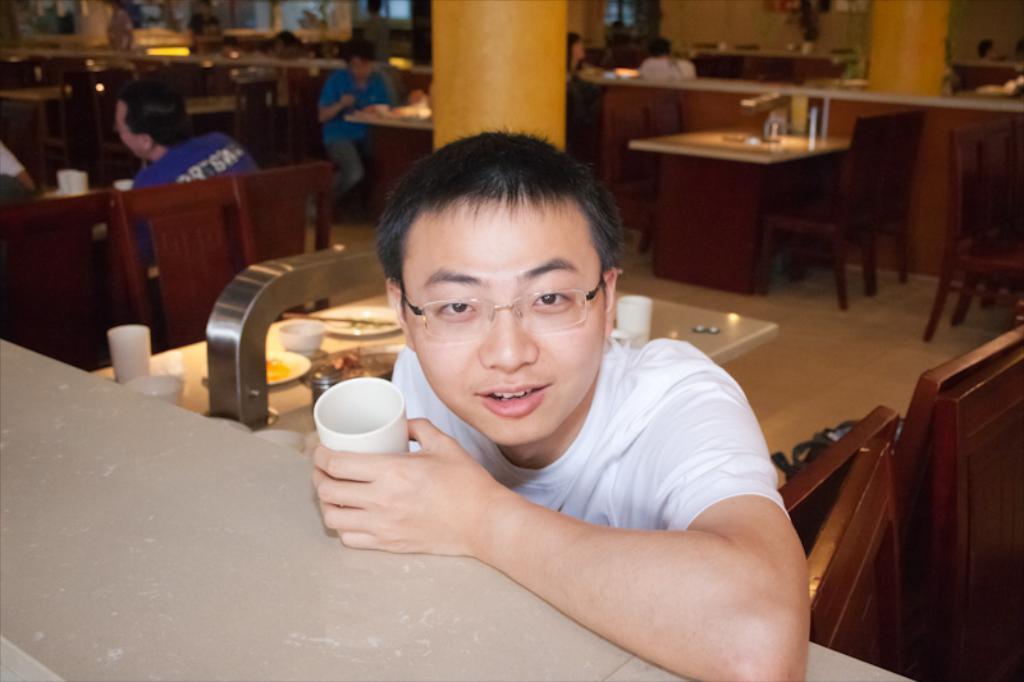Could you give a brief overview of what you see in this image? This picture is taken inside the restaurant. In this image, in the middle, we can see a person in front of the table. On the right side, we can see some chairs. In the background, we can see a table, on the table, we can see some plates, cups, bowl and glasses. In the background, we can also see a group of people sitting on the chair in front of the table, pillars. 